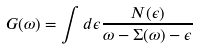<formula> <loc_0><loc_0><loc_500><loc_500>G ( \omega ) = \int d { \epsilon } \frac { N ( \epsilon ) } { \omega - \Sigma ( \omega ) - \epsilon }</formula> 